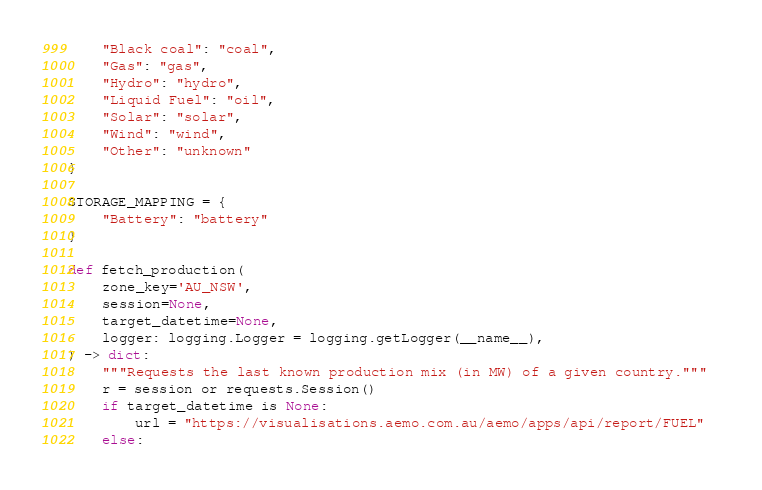<code> <loc_0><loc_0><loc_500><loc_500><_Python_>    "Black coal": "coal",
    "Gas": "gas",
    "Hydro": "hydro",
    "Liquid Fuel": "oil",
    "Solar": "solar",
    "Wind": "wind",
    "Other": "unknown"
}

STORAGE_MAPPING = {
    "Battery": "battery"
}

def fetch_production(
    zone_key='AU_NSW',
    session=None,
    target_datetime=None,
    logger: logging.Logger = logging.getLogger(__name__),
) -> dict:
    """Requests the last known production mix (in MW) of a given country."""
    r = session or requests.Session()
    if target_datetime is None:
        url = "https://visualisations.aemo.com.au/aemo/apps/api/report/FUEL"  
    else:</code> 